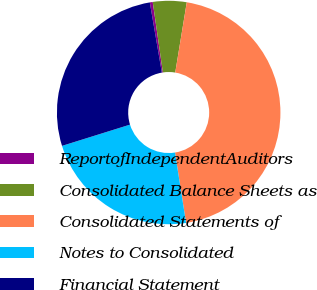Convert chart to OTSL. <chart><loc_0><loc_0><loc_500><loc_500><pie_chart><fcel>ReportofIndependentAuditors<fcel>Consolidated Balance Sheets as<fcel>Consolidated Statements of<fcel>Notes to Consolidated<fcel>Financial Statement<nl><fcel>0.42%<fcel>4.87%<fcel>44.92%<fcel>22.67%<fcel>27.12%<nl></chart> 